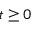Convert formula to latex. <formula><loc_0><loc_0><loc_500><loc_500>t \geq 0</formula> 